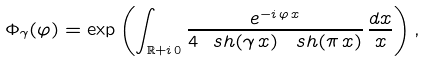<formula> <loc_0><loc_0><loc_500><loc_500>\Phi _ { \gamma } ( \varphi ) = \exp \left ( \int _ { \mathbb { R } + i \, 0 } \frac { e ^ { - i \, \varphi \, x } } { 4 \ s h ( \gamma \, x ) \, \ s h ( \pi \, x ) } \, \frac { d x } { x } \right ) ,</formula> 